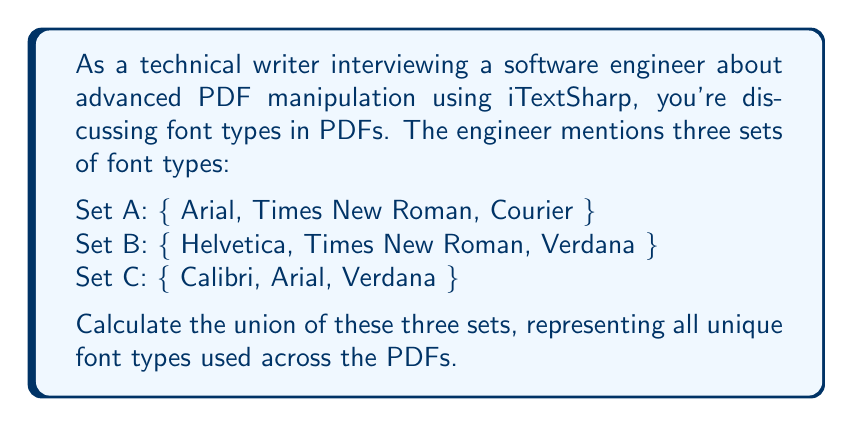Teach me how to tackle this problem. To solve this problem, we need to understand the concept of union in set theory. The union of sets A, B, and C, denoted as $A \cup B \cup C$, is the set of all elements that are in A, or in B, or in C (or in any combination of these sets).

Let's approach this step-by-step:

1) First, let's list all elements from all sets:
   A: Arial, Times New Roman, Courier
   B: Helvetica, Times New Roman, Verdana
   C: Calibri, Arial, Verdana

2) Now, we combine all these elements, but we only list each element once, even if it appears in multiple sets:

   - Arial (from A and C)
   - Times New Roman (from A and B)
   - Courier (from A)
   - Helvetica (from B)
   - Verdana (from B and C)
   - Calibri (from C)

3) The resulting union is the set of all these unique elements.

Mathematically, we can express this as:

$$A \cup B \cup C = \{x : x \in A \text{ or } x \in B \text{ or } x \in C\}$$

Where $x$ represents each font type.
Answer: $A \cup B \cup C = \{$ Arial, Times New Roman, Courier, Helvetica, Verdana, Calibri $\}$ 